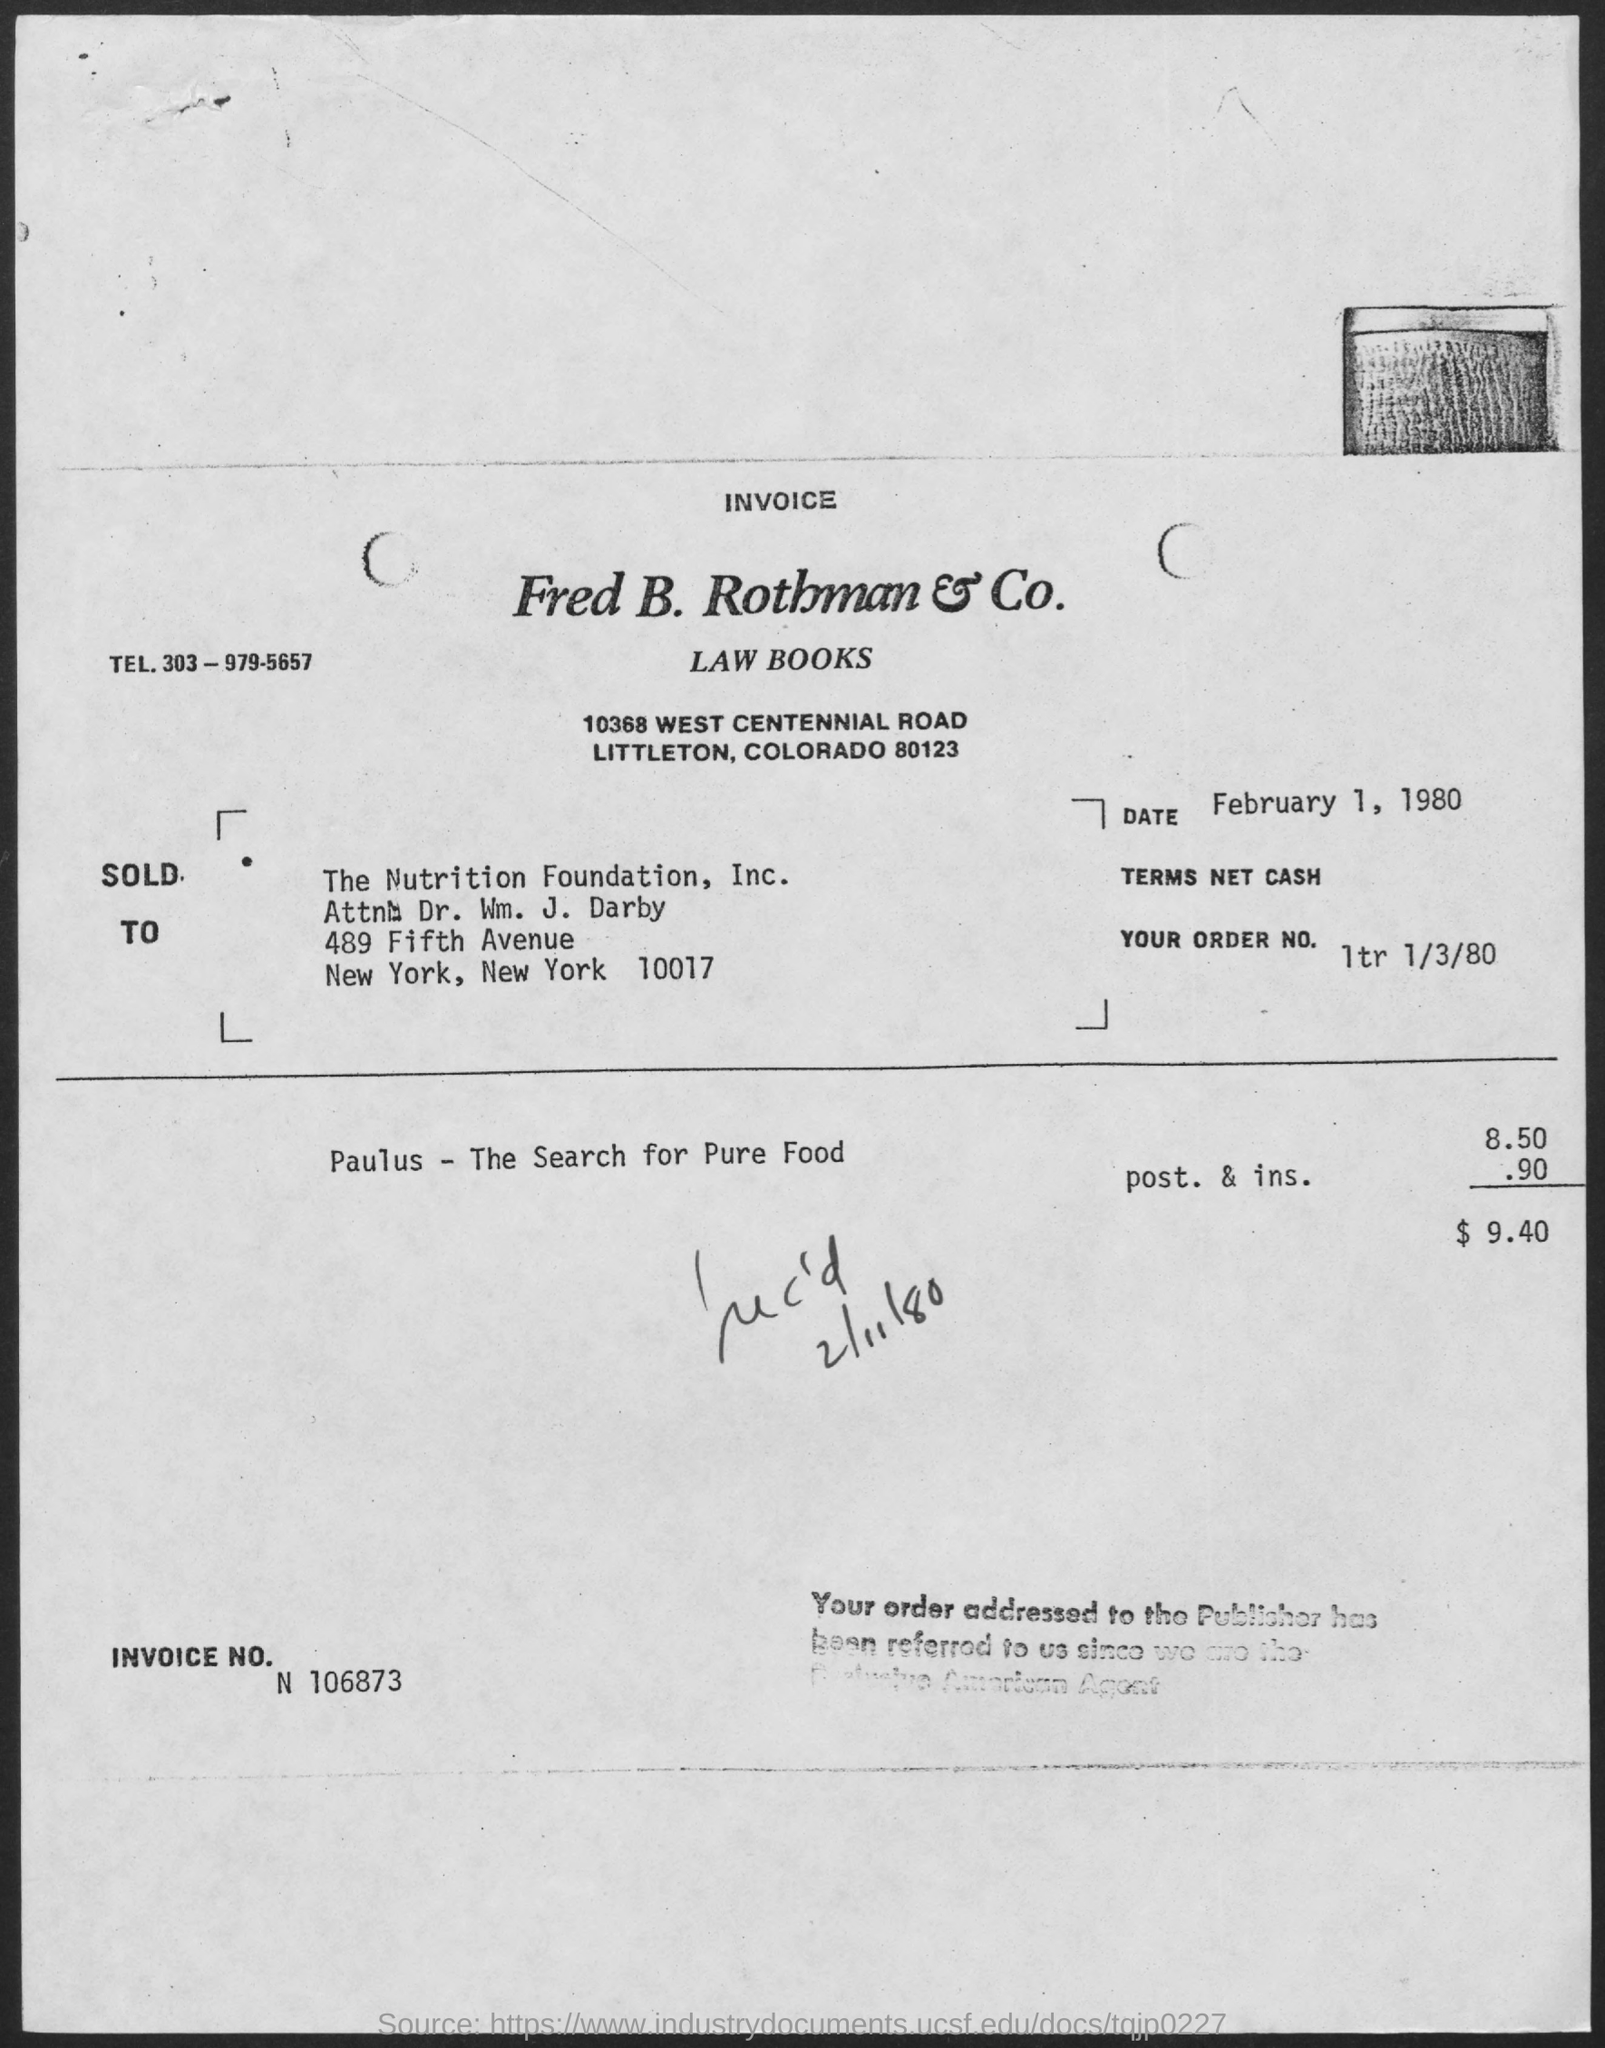What is the date on the document?
Your response must be concise. February 1, 1980. What is the Invoice No.?
Your response must be concise. N 106873. What is the Total amount?
Ensure brevity in your answer.  $ 9.40. 